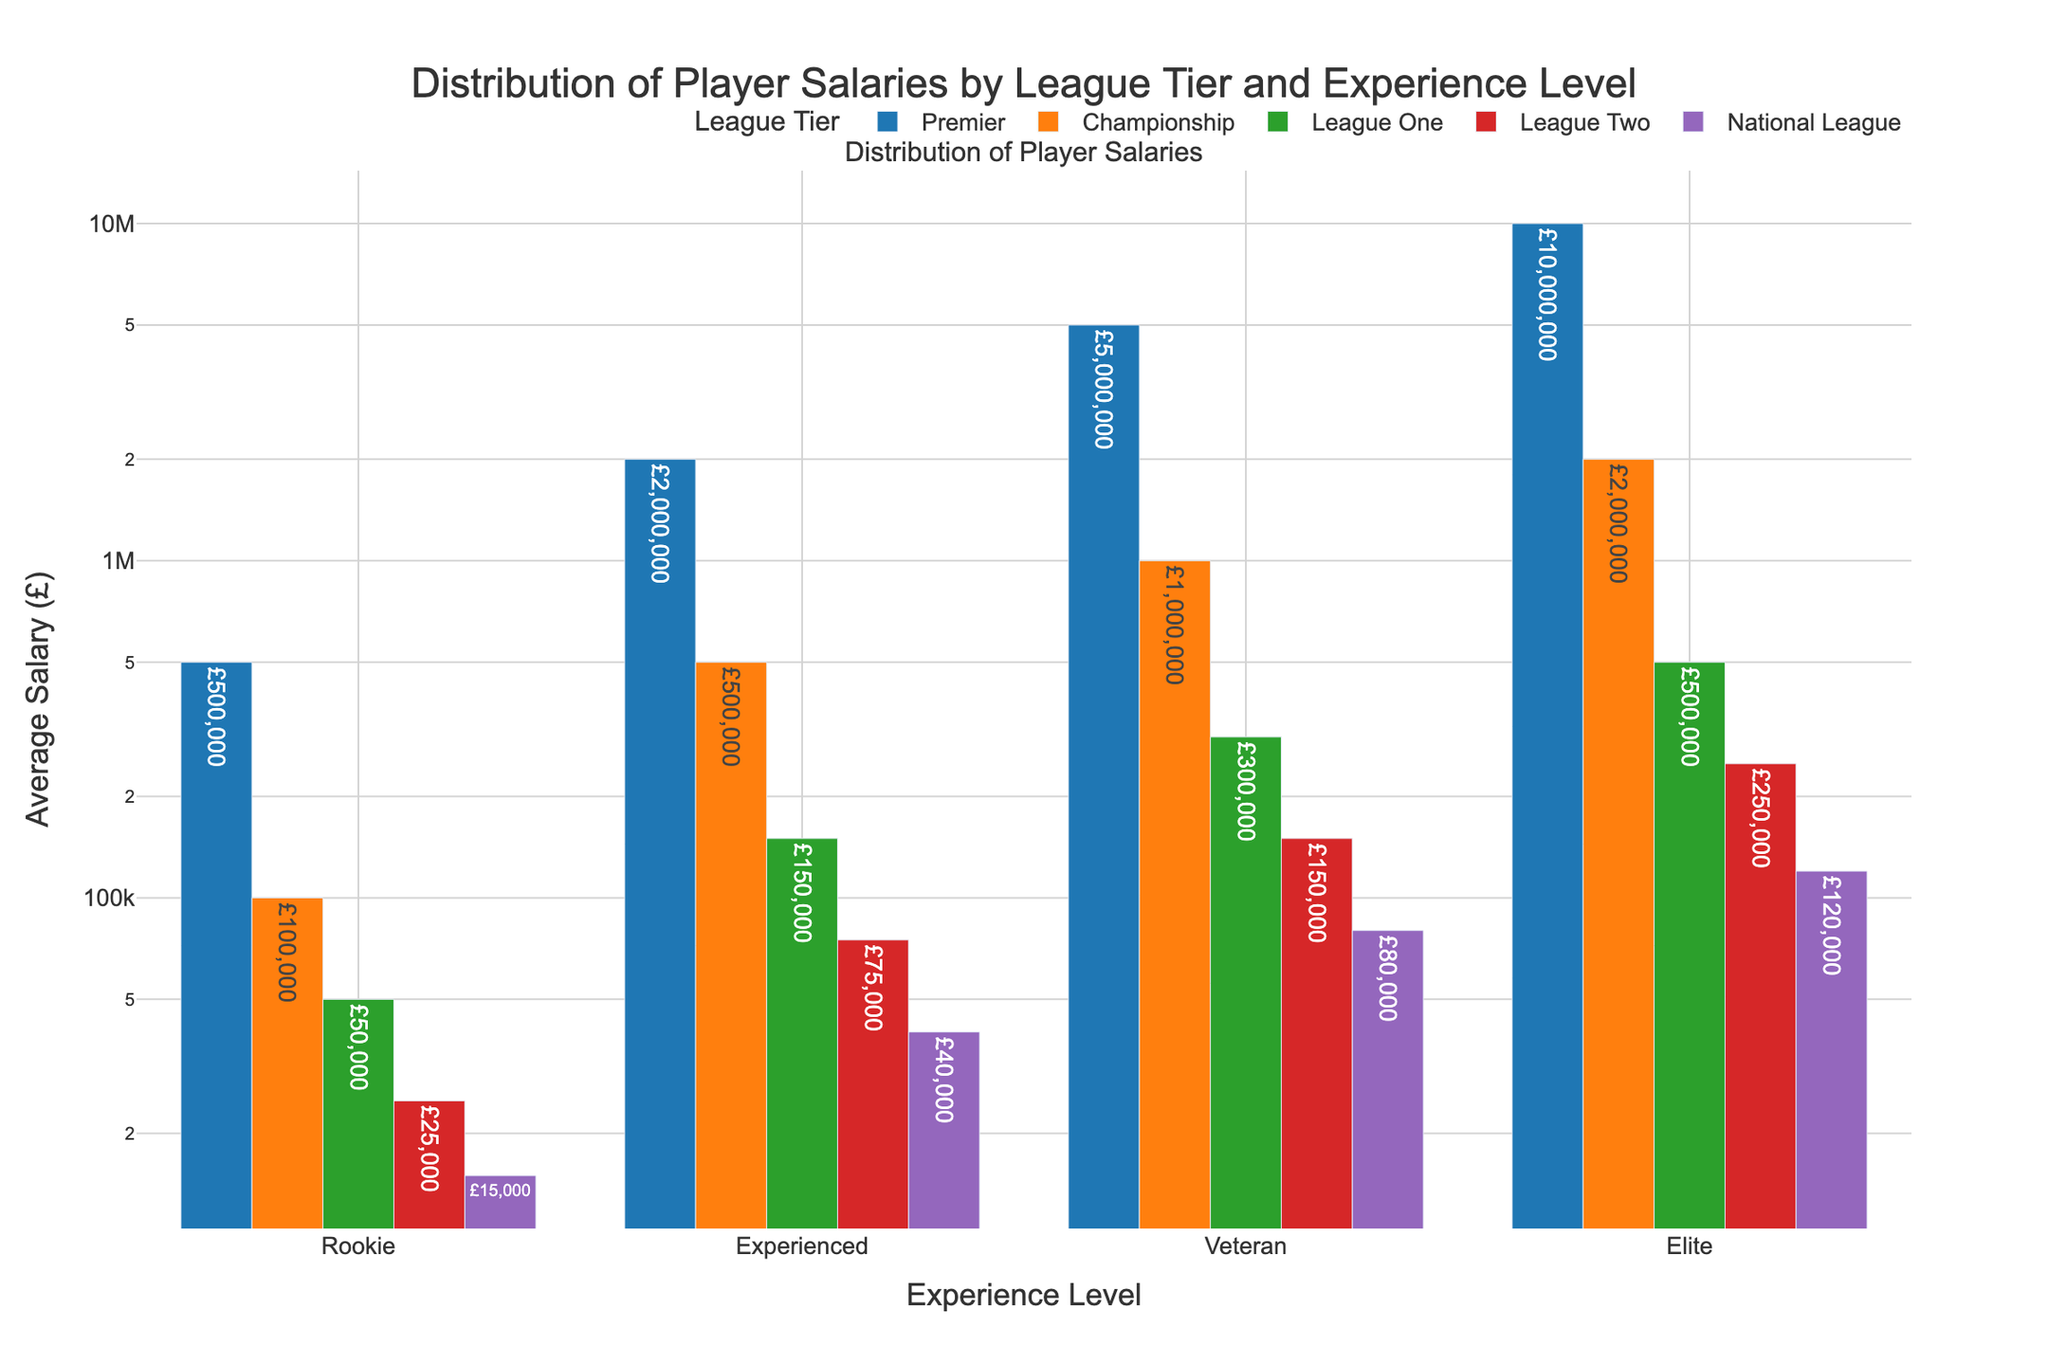Which league tier offers the highest average salary for rookie players? By looking at the bar corresponding to rookie players, we can observe the highest bar. The Premier league tier has the highest bar among rookie players, indicating the highest average salary.
Answer: Premier Which experience level in the Premier tier has the lowest average salary? Within the Premier league tier, we look at the bars corresponding to different experience levels. The lowest bar is for the Rookie experience level.
Answer: Rookie What is the difference in average salary between an Elite player in the Premier tier and an Elite player in the National League? The bar for Elite players in the Premier tier indicates an average salary of £10,000,000, while the bar for Elite players in the National League shows £120,000. The difference is calculated as £10,000,000 - £120,000.
Answer: £9,880,000 How does the average salary of Veteran players in the Championship tier compare to Veteran players in the League Two tier? We compare the heights of the bars representing Veteran players in both tiers. The bar for Championship Veterans is at £1,000,000, while the bar for League Two Veterans is at £150,000. Therefore, Championship Veteran salaries are higher.
Answer: Championship Veterans have higher average salaries What is the total average salary for Rookie players across all league tiers? We add up the average salaries for Rookies in each tier: £500,000 (Premier) + £100,000 (Championship) + £50,000 (League One) + £25,000 (League Two) + £15,000 (National League).
Answer: £690,000 Which experience level shows the most variation in average salaries across different league tiers? By comparing the heights of bars for each experience level across all tiers, we notice that the Elite experience level shows significant variation, with salaries ranging from £10,000,000 in the Premier tier to £120,000 in the National League.
Answer: Elite In terms of the average salary, how much more do Experienced players earn in the Premier tier compared to the Championship tier? Experienced players in the Premier tier earn £2,000,000 on average, while those in the Championship tier earn £500,000. Calculating the difference, £2,000,000 - £500,000 = £1,500,000.
Answer: £1,500,000 Which bar is the tallest in the chart, and what does it represent? The tallest bar in the chart represents Elite players in the Premier tier with an average salary of £10,000,000.
Answer: Elite players in the Premier tier with £10,000,000 